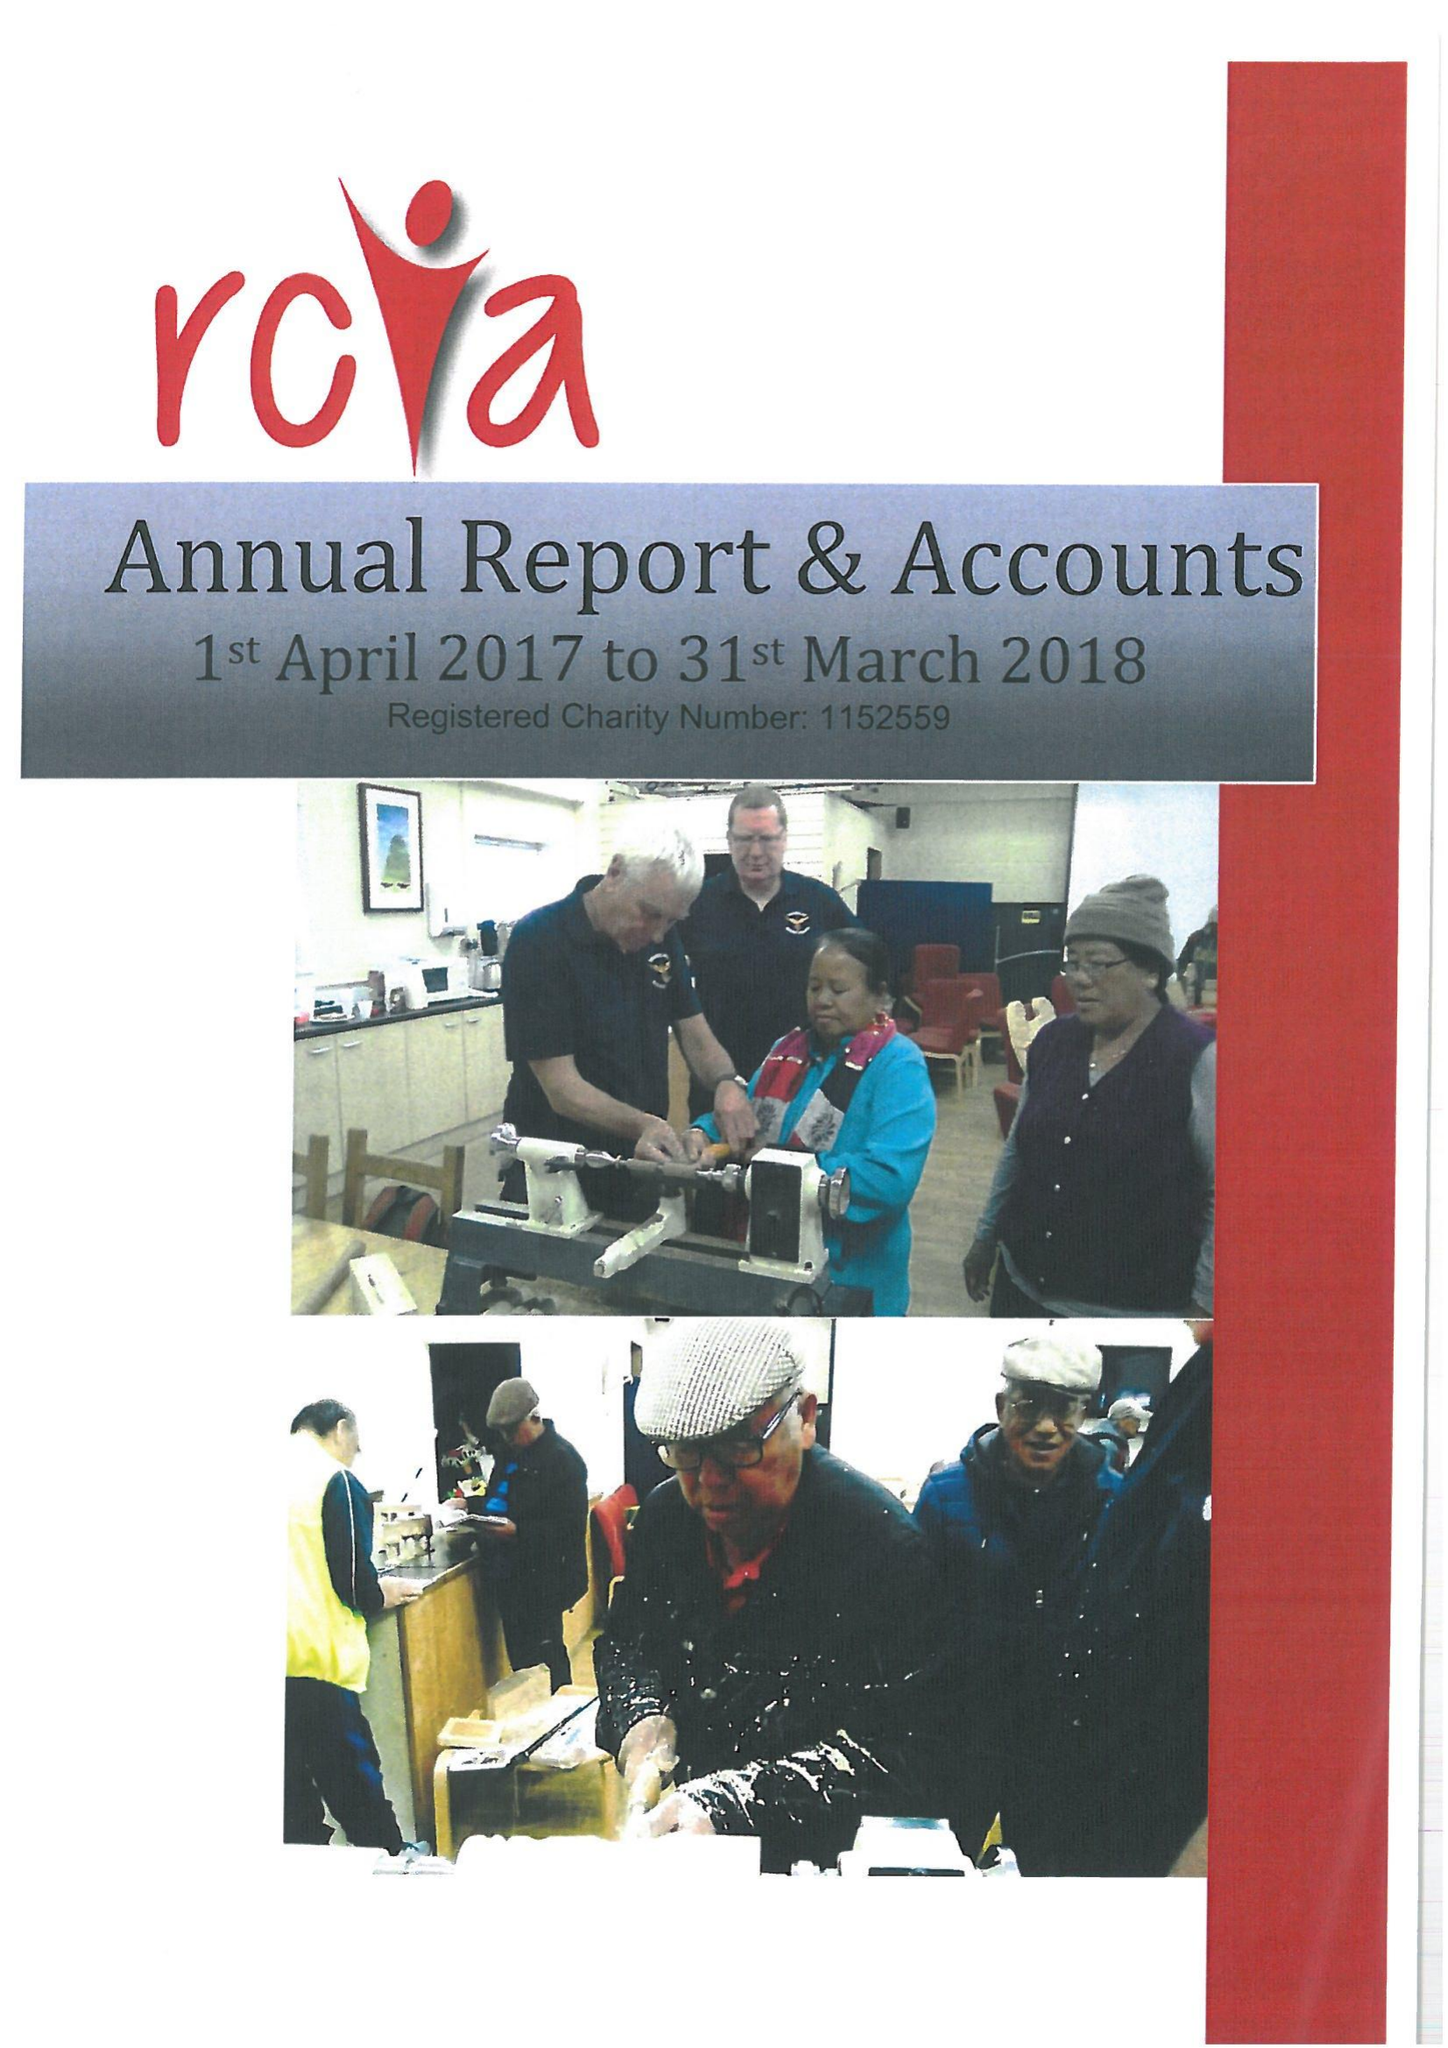What is the value for the address__post_town?
Answer the question using a single word or phrase. CATTERICK GARRISON 